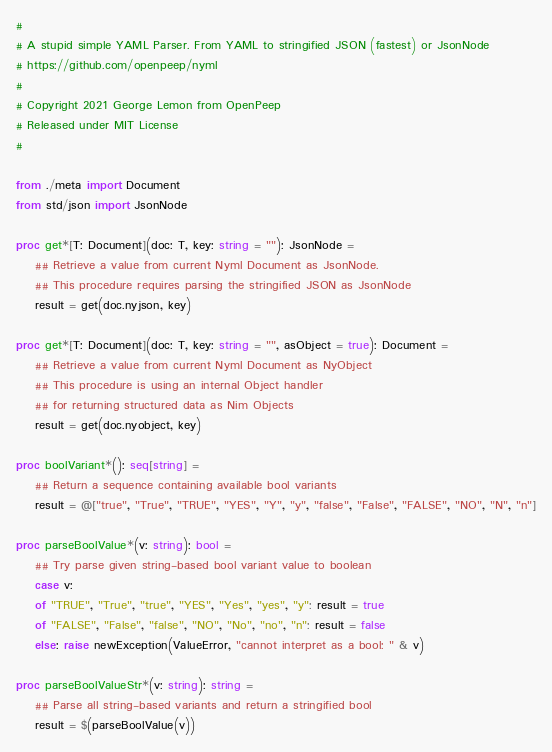<code> <loc_0><loc_0><loc_500><loc_500><_Nim_># 
# A stupid simple YAML Parser. From YAML to stringified JSON (fastest) or JsonNode
# https://github.com/openpeep/nyml
# 
# Copyright 2021 George Lemon from OpenPeep
# Released under MIT License
# 

from ./meta import Document
from std/json import JsonNode

proc get*[T: Document](doc: T, key: string = ""): JsonNode =
    ## Retrieve a value from current Nyml Document as JsonNode.
    ## This procedure requires parsing the stringified JSON as JsonNode
    result = get(doc.nyjson, key)

proc get*[T: Document](doc: T, key: string = "", asObject = true): Document =
    ## Retrieve a value from current Nyml Document as NyObject
    ## This procedure is using an internal Object handler
    ## for returning structured data as Nim Objects
    result = get(doc.nyobject, key)

proc boolVariant*(): seq[string] = 
    ## Return a sequence containing available bool variants
    result = @["true", "True", "TRUE", "YES", "Y", "y", "false", "False", "FALSE", "NO", "N", "n"]

proc parseBoolValue*(v: string): bool =
    ## Try parse given string-based bool variant value to boolean
    case v:
    of "TRUE", "True", "true", "YES", "Yes", "yes", "y": result = true
    of "FALSE", "False", "false", "NO", "No", "no", "n": result = false
    else: raise newException(ValueError, "cannot interpret as a bool: " & v)

proc parseBoolValueStr*(v: string): string =
    ## Parse all string-based variants and return a stringified bool
    result = $(parseBoolValue(v))</code> 